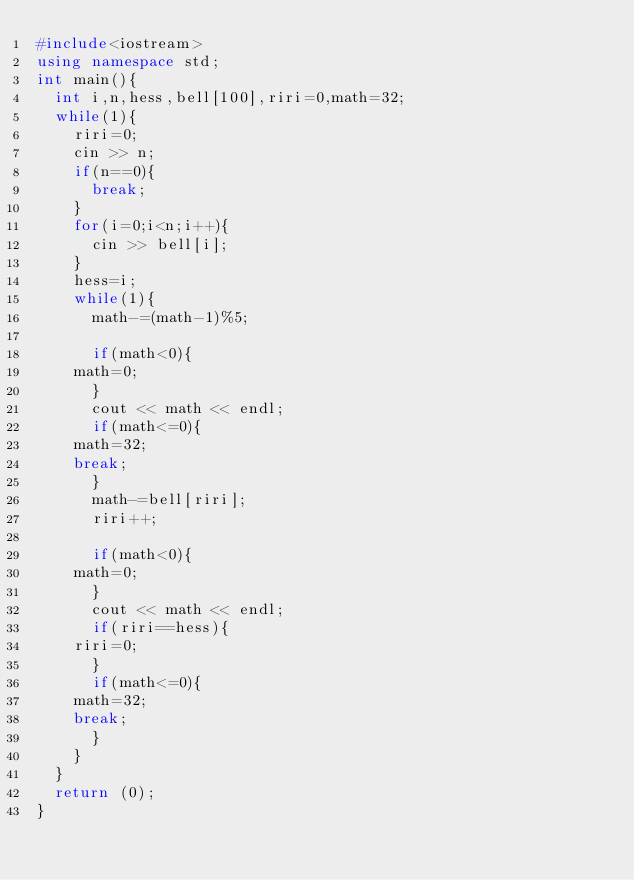Convert code to text. <code><loc_0><loc_0><loc_500><loc_500><_C++_>#include<iostream>
using namespace std;
int main(){
  int i,n,hess,bell[100],riri=0,math=32;
  while(1){
    riri=0;
    cin >> n;
    if(n==0){
      break;
    }
    for(i=0;i<n;i++){
      cin >> bell[i];
    }
    hess=i;
    while(1){
      math-=(math-1)%5;

      if(math<0){
	math=0;
      }
      cout << math << endl;
      if(math<=0){
	math=32;
	break;
      }
      math-=bell[riri];
      riri++;

      if(math<0){
	math=0;
      }
      cout << math << endl;
      if(riri==hess){
	riri=0;
      }
      if(math<=0){
	math=32;
	break;
      }
    }
  }
  return (0);
}</code> 